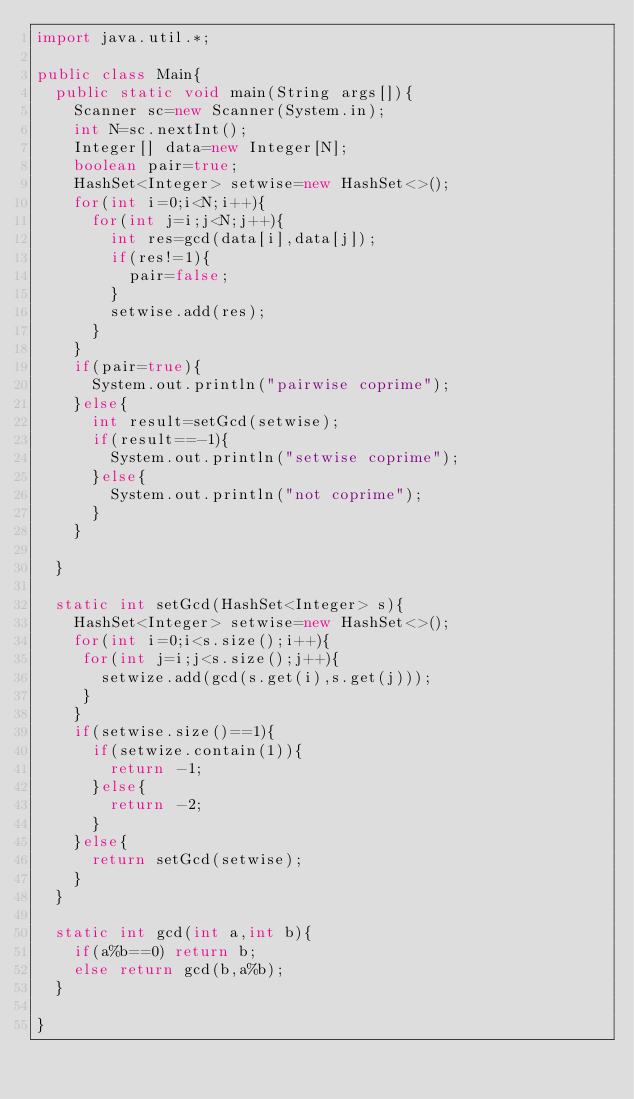Convert code to text. <code><loc_0><loc_0><loc_500><loc_500><_Java_>import java.util.*;

public class Main{
  public static void main(String args[]){
    Scanner sc=new Scanner(System.in);
    int N=sc.nextInt();
    Integer[] data=new Integer[N];
	boolean pair=true;
    HashSet<Integer> setwise=new HashSet<>();
    for(int i=0;i<N;i++){
      for(int j=i;j<N;j++){
        int res=gcd(data[i],data[j]);
        if(res!=1){
          pair=false;
        }
		setwise.add(res);
      }
    }
    if(pair=true){
      System.out.println("pairwise coprime");
    }else{
      int result=setGcd(setwise);
      if(result==-1){
        System.out.println("setwise coprime");
      }else{
        System.out.println("not coprime");
      }
    }
  
  }
  
  static int setGcd(HashSet<Integer> s){
    HashSet<Integer> setwise=new HashSet<>();
	for(int i=0;i<s.size();i++){
     for(int j=i;j<s.size();j++){
       setwize.add(gcd(s.get(i),s.get(j)));
     }
    }
    if(setwise.size()==1){
      if(setwize.contain(1)){
        return -1;
      }else{
        return -2;
      }
    }else{
      return setGcd(setwise);
    }
  }
  
  static int gcd(int a,int b){
    if(a%b==0) return b;
	else return gcd(b,a%b);    
  }
  
}</code> 